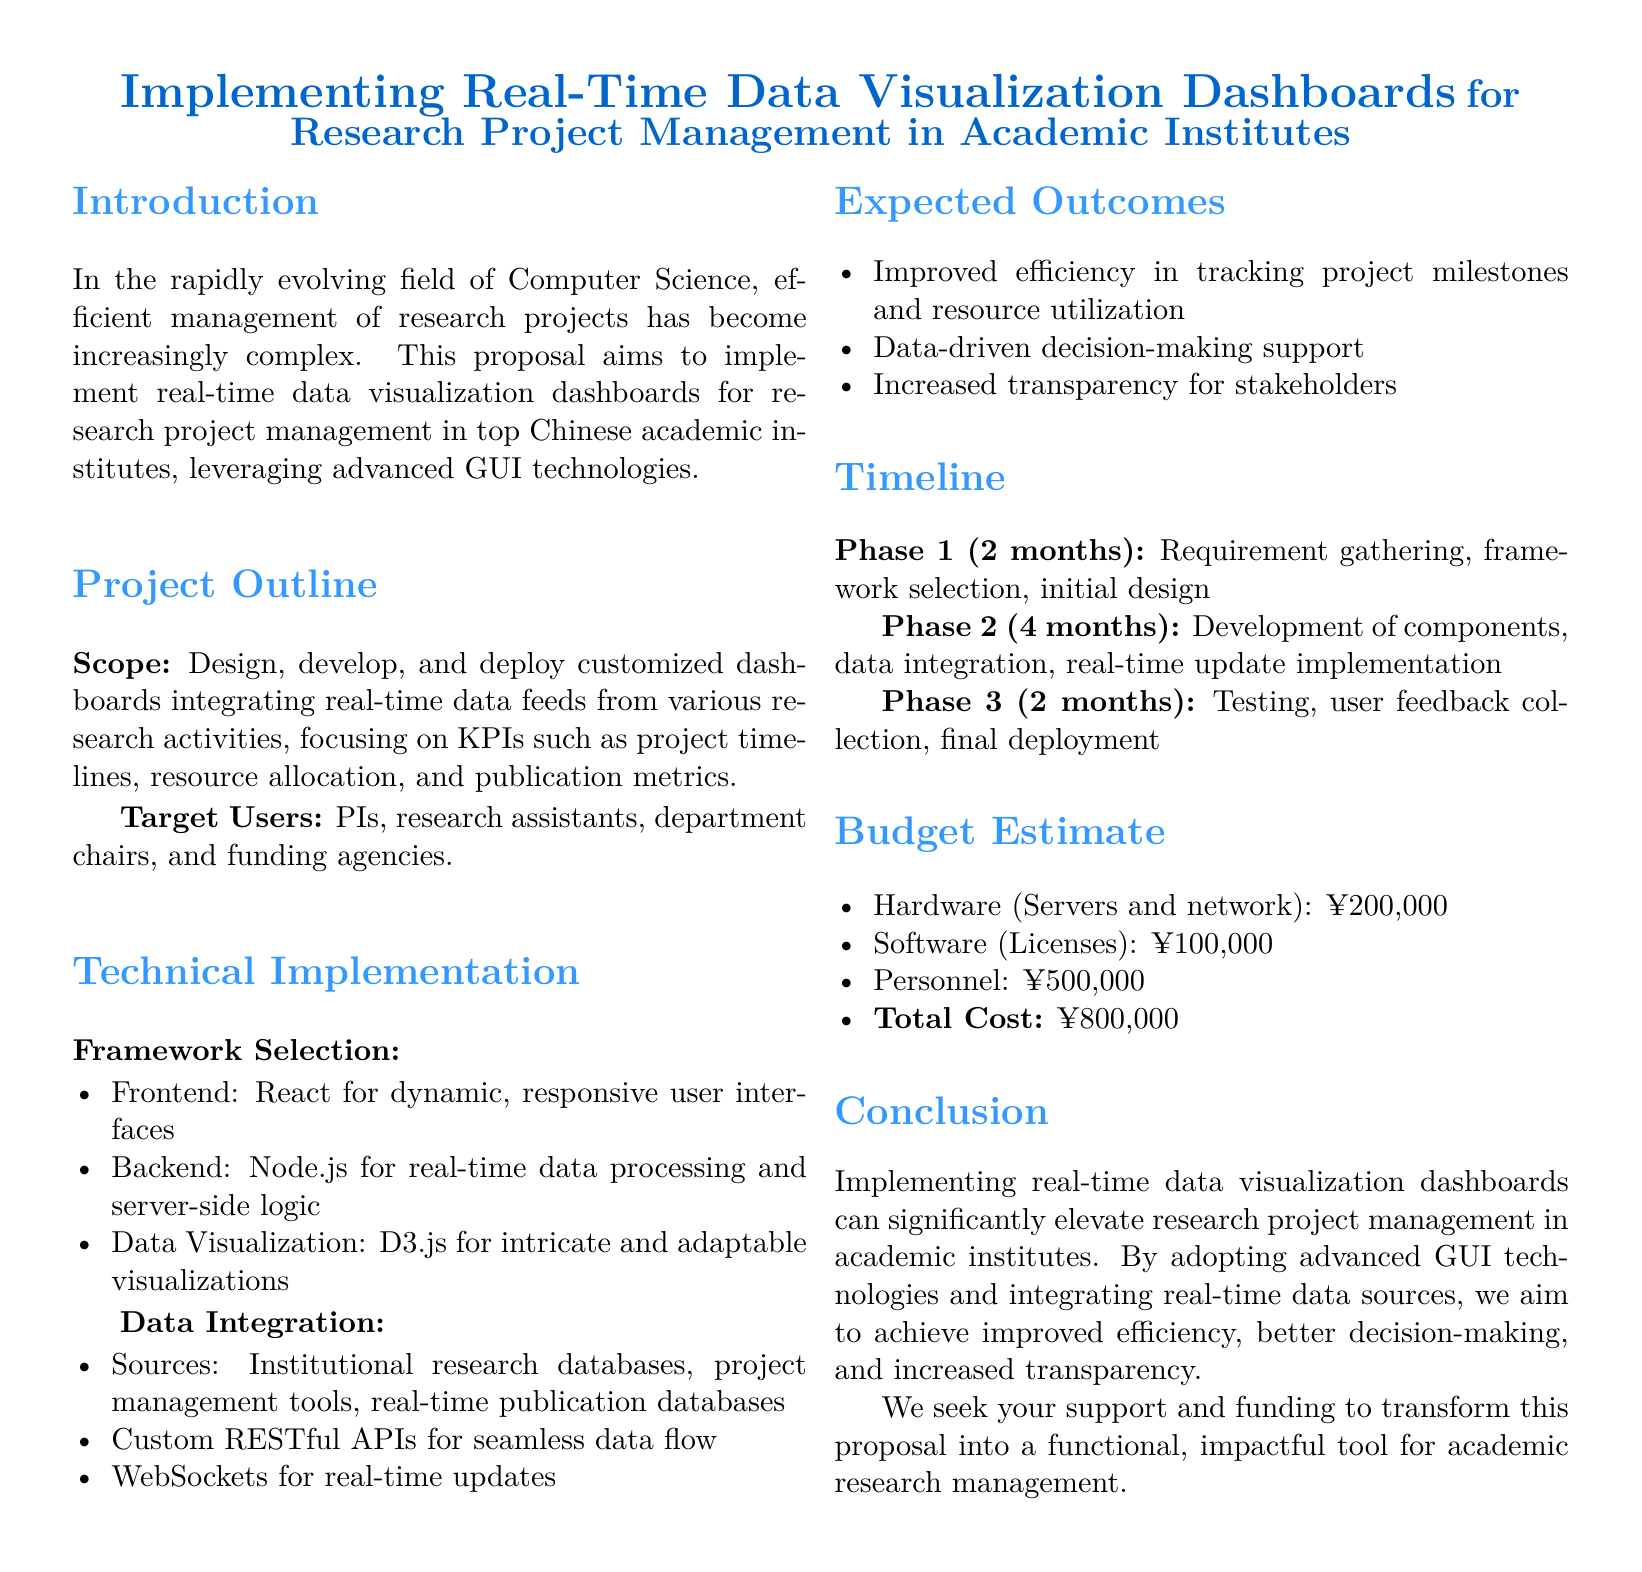What is the total cost for the project? The total cost is explicitly stated in the budget estimate section of the document.
Answer: ¥800,000 Who are the target users of the dashboards? The target users are explicitly listed in the project outline section.
Answer: PIs, research assistants, department chairs, and funding agencies What is the duration of Phase 1? The duration of Phase 1 is mentioned in the timeline section of the document.
Answer: 2 months Which frontend framework is selected? The chosen frontend framework is specified in the technical implementation section.
Answer: React What is the primary purpose of the proposal? The overall intent of the proposal is described in the introduction section.
Answer: Implement real-time data visualization dashboards How many phases are outlined in the project timeline? The total number of phases is mentioned in the timeline section.
Answer: 3 phases Which data visualization library is mentioned? The specific library for data visualization is detailed in the technical implementation section.
Answer: D3.js What will improve as an expected outcome? The expected outcomes are listed in the respective section of the document.
Answer: Efficiency in tracking project milestones What are the software license costs? The software cost is provided in the budget estimate section.
Answer: ¥100,000 